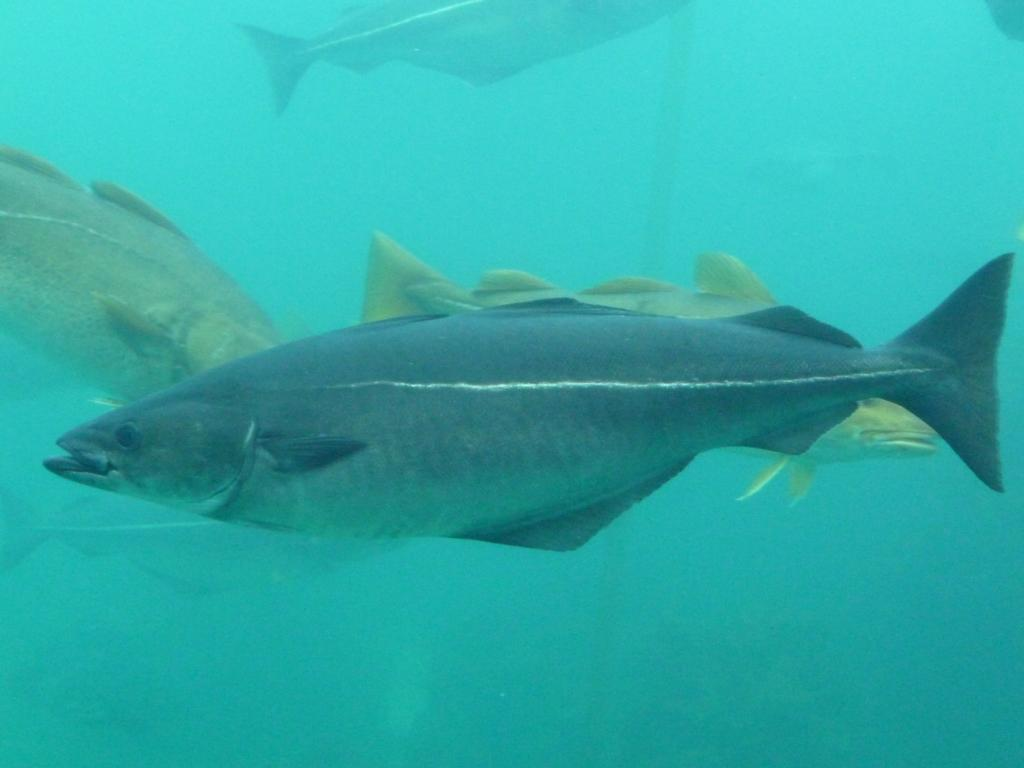What type of animals are in the image? There are fish in the image. Where are the fish located? The fish are in the water. How are the fish measuring the distance between them in the image? The fish are not measuring the distance between them in the image; they are simply swimming in the water. 